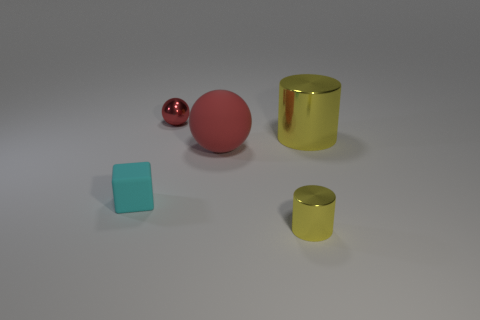Add 4 matte spheres. How many objects exist? 9 Subtract all balls. How many objects are left? 3 Add 4 small blue cylinders. How many small blue cylinders exist? 4 Subtract 0 purple balls. How many objects are left? 5 Subtract all yellow metal things. Subtract all large yellow objects. How many objects are left? 2 Add 1 tiny cylinders. How many tiny cylinders are left? 2 